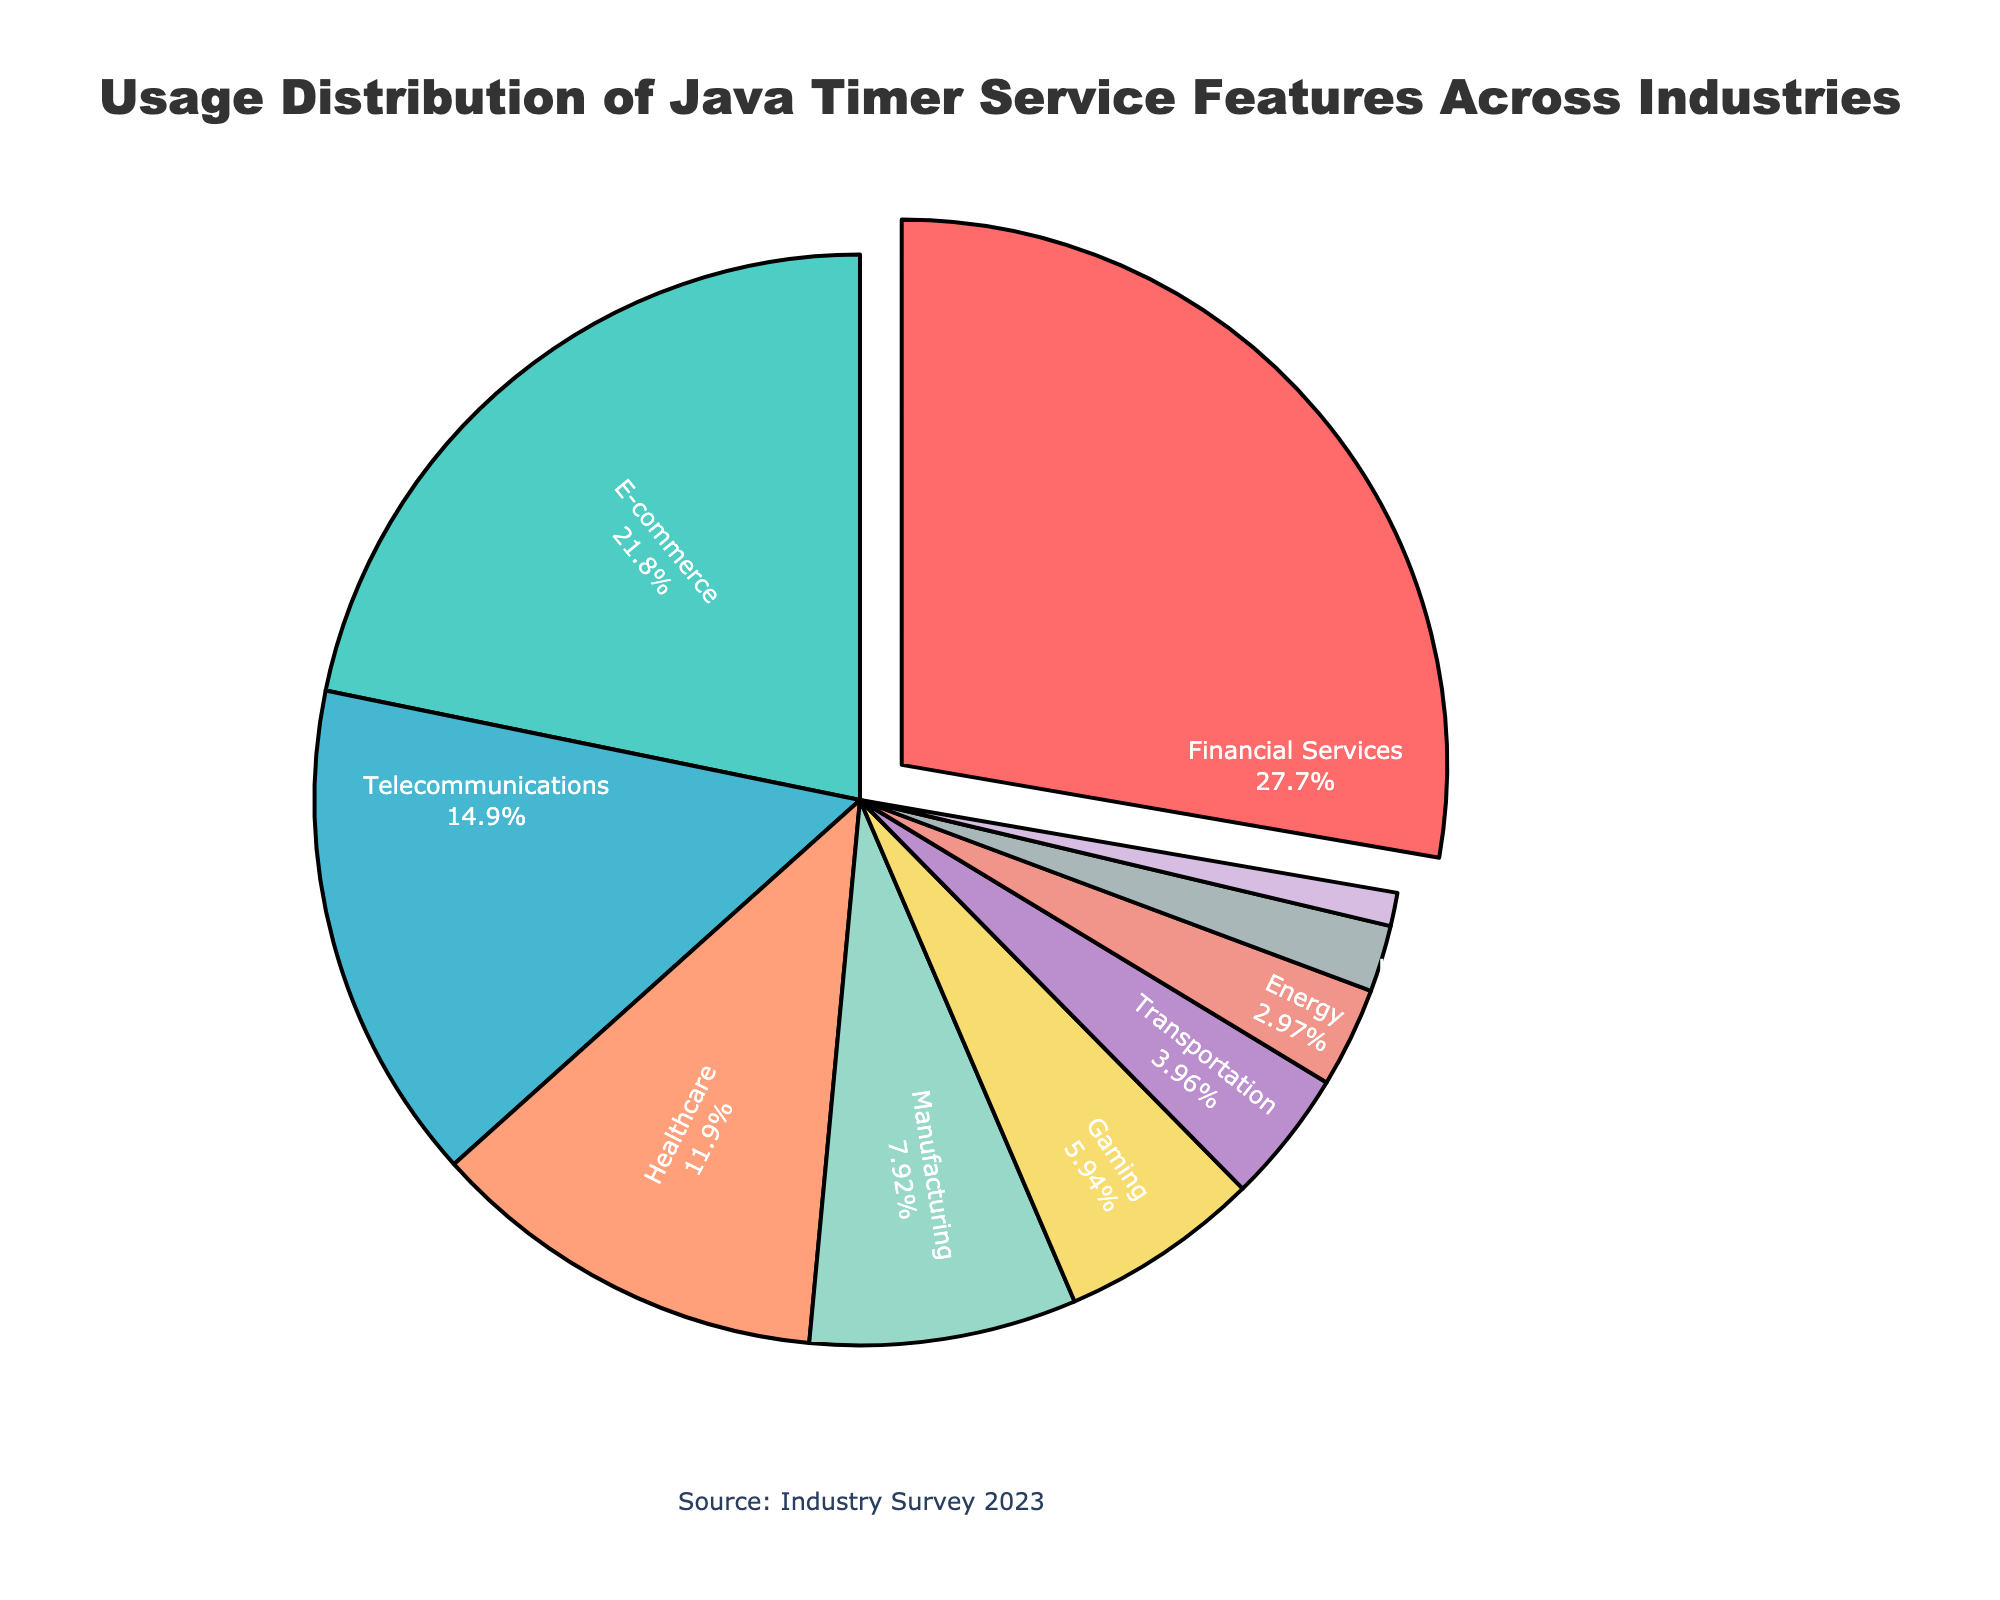Which industry has the largest usage percentage of Java timer service features? The figure shows various industries with corresponding usage percentages. By inspecting the figure, we observe that the financial services sector has the largest portion highlighted in the pie chart.
Answer: Financial Services What's the total percentage of usage among the top three industries? Identify the top three industries by percentage: Financial Services (28%), E-commerce (22%), and Telecommunications (15%). Sum these percentages: 28 + 22 + 15 = 65.
Answer: 65 How does the usage percentage of the Healthcare industry compare to the Manufacturing industry? The pie chart indicates percentages: Healthcare (12%) and Manufacturing (8%). Comparing these two values, Healthcare has a higher usage percentage.
Answer: Healthcare is higher What is the difference in usage percentage between Gaming and Transportation industries? Look at the percentages from the pie chart: Gaming (6%) and Transportation (4%). Calculate the difference: 6 - 4 = 2.
Answer: 2 Which industry uses Java timer service features the least? Examine the smallest section of the pie chart, which is highlighted and labeled as Media & Entertainment with a percentage of 1%.
Answer: Media & Entertainment How many industries have a usage percentage of 10% or higher? Check each industry's percentage on the pie chart and count those 10% or higher: Financial Services (28%), E-commerce (22%), Telecommunications (15%), Healthcare (12%).
Answer: 4 What is the combined usage percentage of the Transportation, Energy, and Education industries? Sum the percentages of these industries: Transportation (4%), Energy (3%), and Education (2%): 4 + 3 + 2 = 9.
Answer: 9 What is the percentage difference between the industry with the highest usage and the industry with the lowest usage? Compare Financial Services (28%) and Media & Entertainment (1%) percentages. Calculate the difference: 28 - 1 = 27.
Answer: 27 What color represents the Manufacturing industry in the pie chart? The pie chart uses a color scheme where each sector is distinctly colored. The Manufacturing industry is represented by the fifth sector, which is colored in a light purple hue.
Answer: Light purple What percentage of total usage is attributable to industries other than Financial Services and E-commerce? First, find the combined percentage of Financial Services and E-commerce: 28% + 22% = 50%. Then subtract this from the total (100%): 100% - 50% = 50%.
Answer: 50 